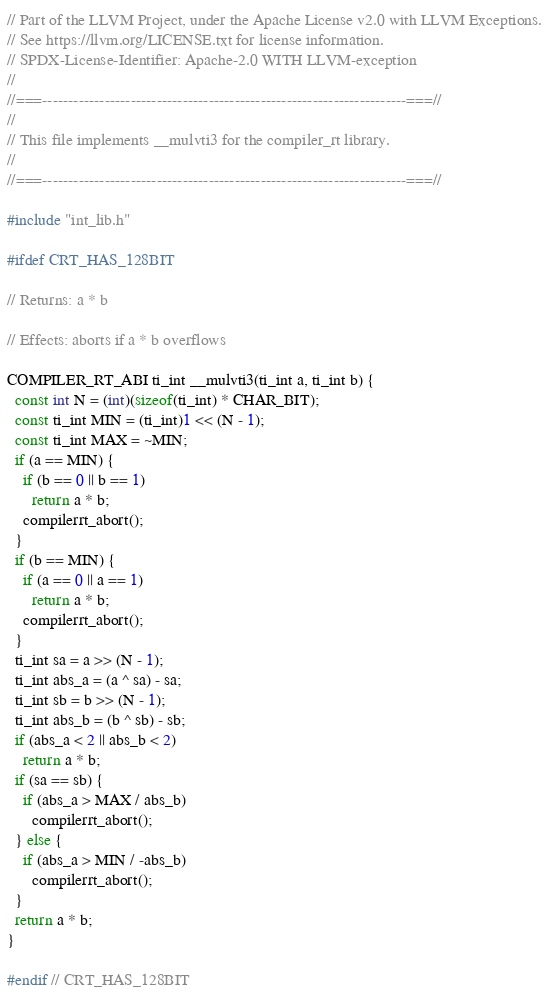<code> <loc_0><loc_0><loc_500><loc_500><_C_>// Part of the LLVM Project, under the Apache License v2.0 with LLVM Exceptions.
// See https://llvm.org/LICENSE.txt for license information.
// SPDX-License-Identifier: Apache-2.0 WITH LLVM-exception
//
//===----------------------------------------------------------------------===//
//
// This file implements __mulvti3 for the compiler_rt library.
//
//===----------------------------------------------------------------------===//

#include "int_lib.h"

#ifdef CRT_HAS_128BIT

// Returns: a * b

// Effects: aborts if a * b overflows

COMPILER_RT_ABI ti_int __mulvti3(ti_int a, ti_int b) {
  const int N = (int)(sizeof(ti_int) * CHAR_BIT);
  const ti_int MIN = (ti_int)1 << (N - 1);
  const ti_int MAX = ~MIN;
  if (a == MIN) {
    if (b == 0 || b == 1)
      return a * b;
    compilerrt_abort();
  }
  if (b == MIN) {
    if (a == 0 || a == 1)
      return a * b;
    compilerrt_abort();
  }
  ti_int sa = a >> (N - 1);
  ti_int abs_a = (a ^ sa) - sa;
  ti_int sb = b >> (N - 1);
  ti_int abs_b = (b ^ sb) - sb;
  if (abs_a < 2 || abs_b < 2)
    return a * b;
  if (sa == sb) {
    if (abs_a > MAX / abs_b)
      compilerrt_abort();
  } else {
    if (abs_a > MIN / -abs_b)
      compilerrt_abort();
  }
  return a * b;
}

#endif // CRT_HAS_128BIT
</code> 